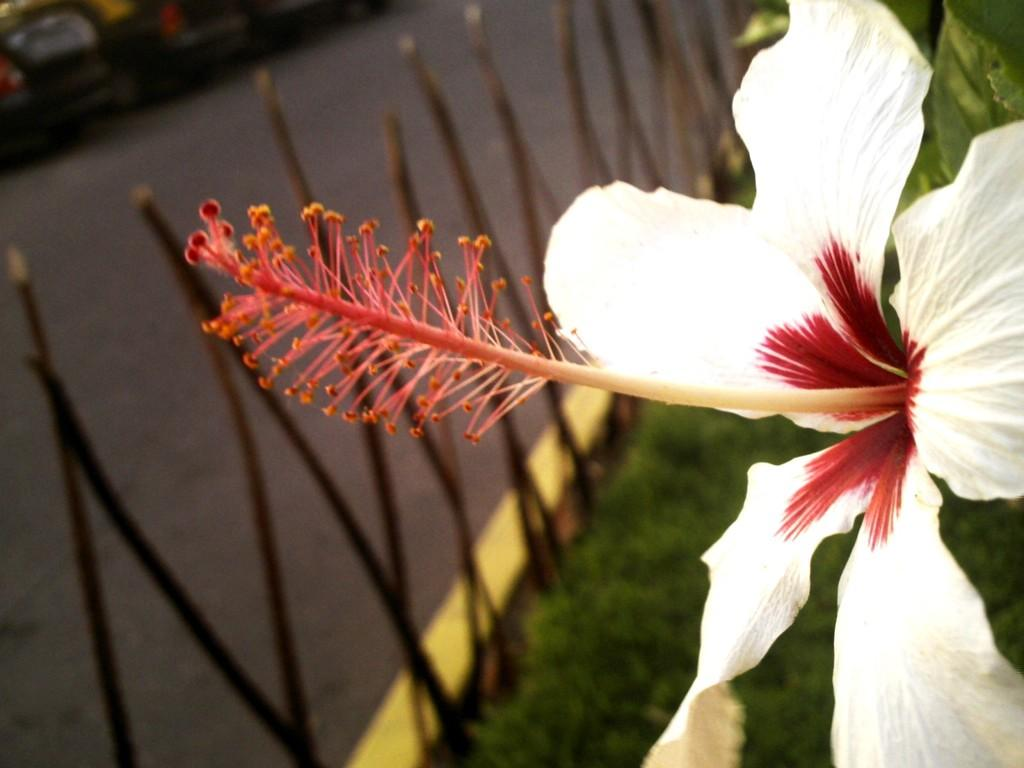What is the main subject in the foreground of the picture? There is a flower in the foreground of the picture. How would you describe the background of the image? The background of the image is blurred. What type of natural environment can be seen in the background? There is grass in the background of the image. What man-made structures are visible in the background? There is a railing and a road in the background of the image. What type of vehicles can be seen in the background? There are autos in the background of the image. Is the flower lying on a gold bed in the image? No, there is no gold bed present in the image. The flower is in the foreground, and the background is blurred with grass, a railing, a road, and autos visible. 